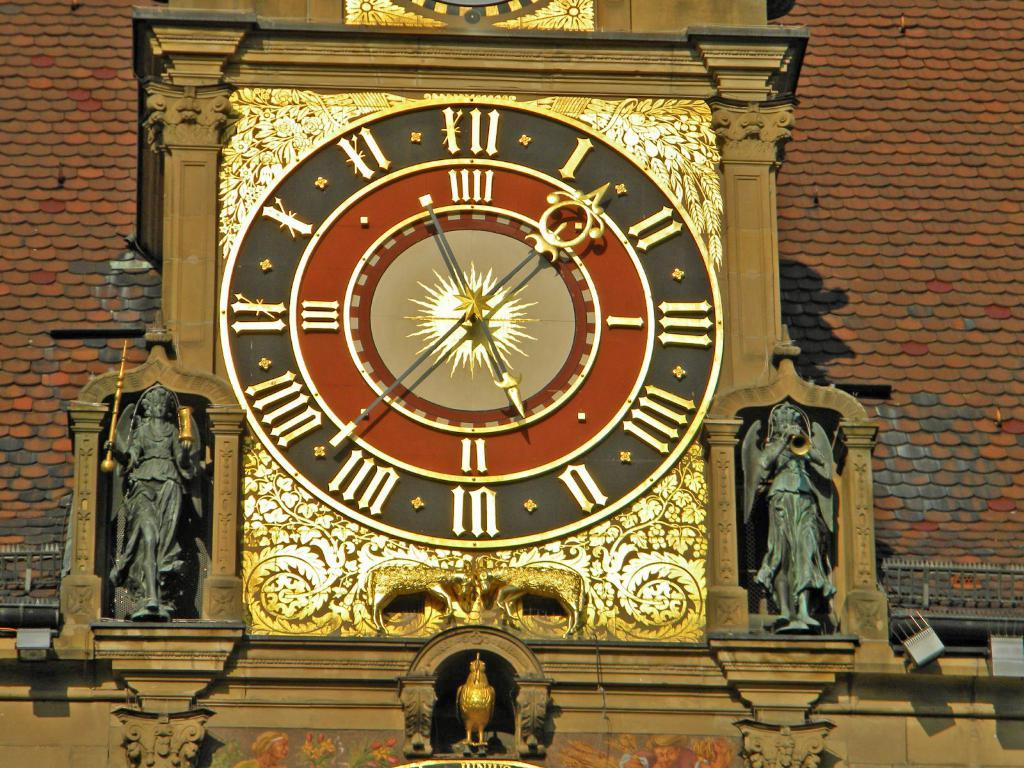<image>
Describe the image concisely. A large clock with Roman numerals also has a I next to the number 3, and II next to 6, and III next to the nine on the clock. 